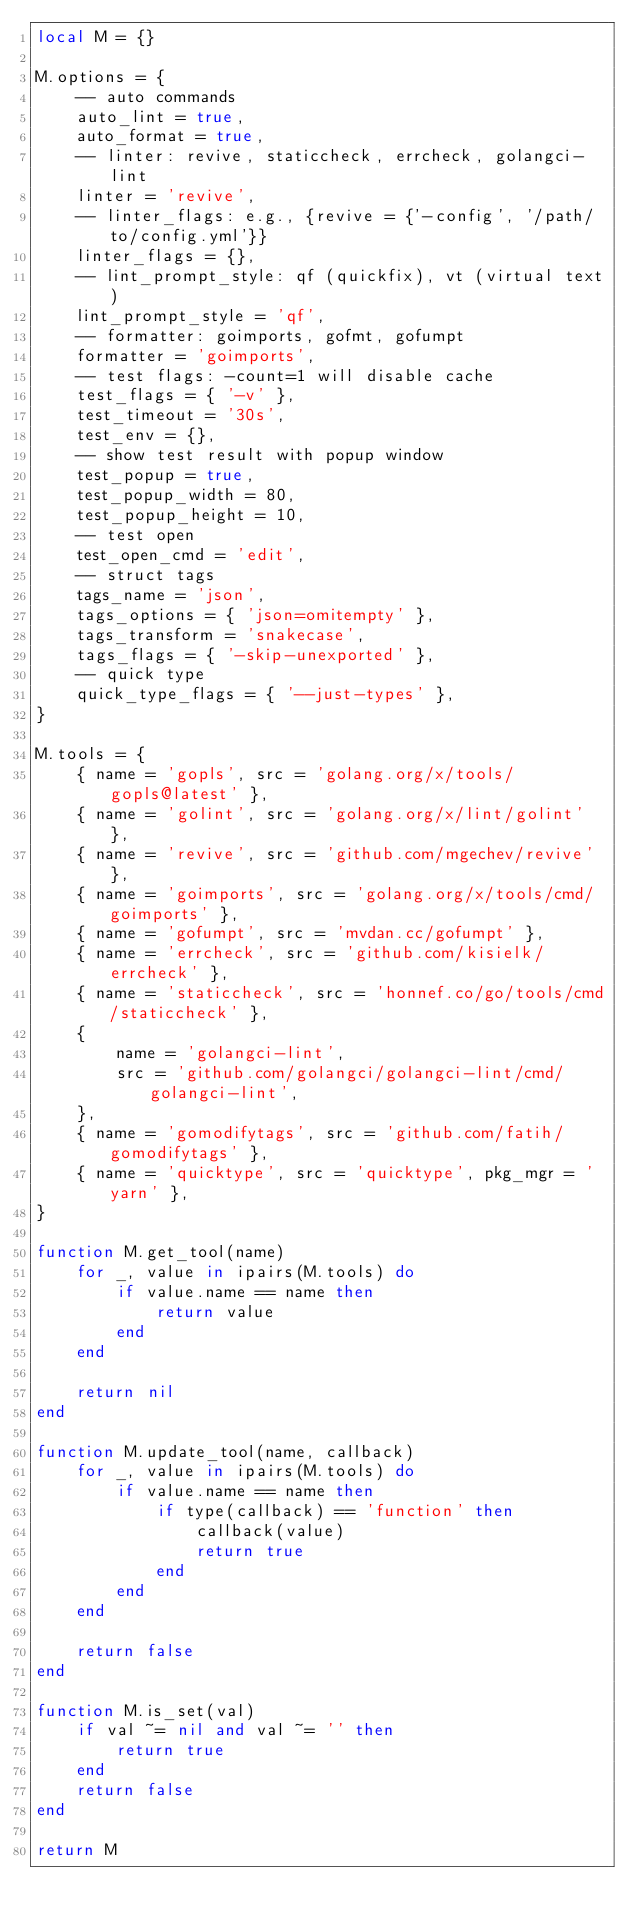Convert code to text. <code><loc_0><loc_0><loc_500><loc_500><_Lua_>local M = {}

M.options = {
    -- auto commands
    auto_lint = true,
    auto_format = true,
    -- linter: revive, staticcheck, errcheck, golangci-lint
    linter = 'revive',
    -- linter_flags: e.g., {revive = {'-config', '/path/to/config.yml'}}
    linter_flags = {},
    -- lint_prompt_style: qf (quickfix), vt (virtual text)
    lint_prompt_style = 'qf',
    -- formatter: goimports, gofmt, gofumpt
    formatter = 'goimports',
    -- test flags: -count=1 will disable cache
    test_flags = { '-v' },
    test_timeout = '30s',
    test_env = {},
    -- show test result with popup window
    test_popup = true,
    test_popup_width = 80,
    test_popup_height = 10,
    -- test open
    test_open_cmd = 'edit',
    -- struct tags
    tags_name = 'json',
    tags_options = { 'json=omitempty' },
    tags_transform = 'snakecase',
    tags_flags = { '-skip-unexported' },
    -- quick type
    quick_type_flags = { '--just-types' },
}

M.tools = {
    { name = 'gopls', src = 'golang.org/x/tools/gopls@latest' },
    { name = 'golint', src = 'golang.org/x/lint/golint' },
    { name = 'revive', src = 'github.com/mgechev/revive' },
    { name = 'goimports', src = 'golang.org/x/tools/cmd/goimports' },
    { name = 'gofumpt', src = 'mvdan.cc/gofumpt' },
    { name = 'errcheck', src = 'github.com/kisielk/errcheck' },
    { name = 'staticcheck', src = 'honnef.co/go/tools/cmd/staticcheck' },
    {
        name = 'golangci-lint',
        src = 'github.com/golangci/golangci-lint/cmd/golangci-lint',
    },
    { name = 'gomodifytags', src = 'github.com/fatih/gomodifytags' },
    { name = 'quicktype', src = 'quicktype', pkg_mgr = 'yarn' },
}

function M.get_tool(name)
    for _, value in ipairs(M.tools) do
        if value.name == name then
            return value
        end
    end

    return nil
end

function M.update_tool(name, callback)
    for _, value in ipairs(M.tools) do
        if value.name == name then
            if type(callback) == 'function' then
                callback(value)
                return true
            end
        end
    end

    return false
end

function M.is_set(val)
    if val ~= nil and val ~= '' then
        return true
    end
    return false
end

return M
</code> 